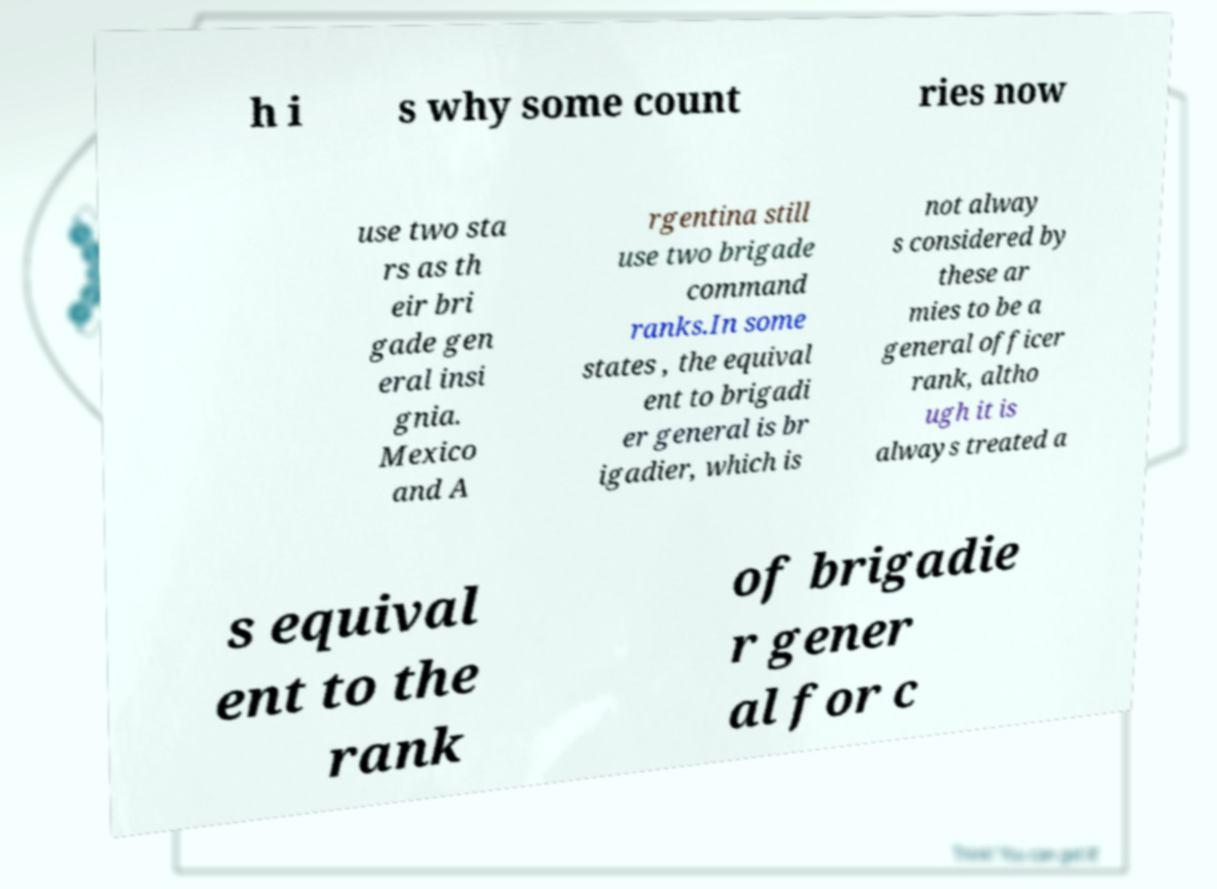Could you assist in decoding the text presented in this image and type it out clearly? h i s why some count ries now use two sta rs as th eir bri gade gen eral insi gnia. Mexico and A rgentina still use two brigade command ranks.In some states , the equival ent to brigadi er general is br igadier, which is not alway s considered by these ar mies to be a general officer rank, altho ugh it is always treated a s equival ent to the rank of brigadie r gener al for c 